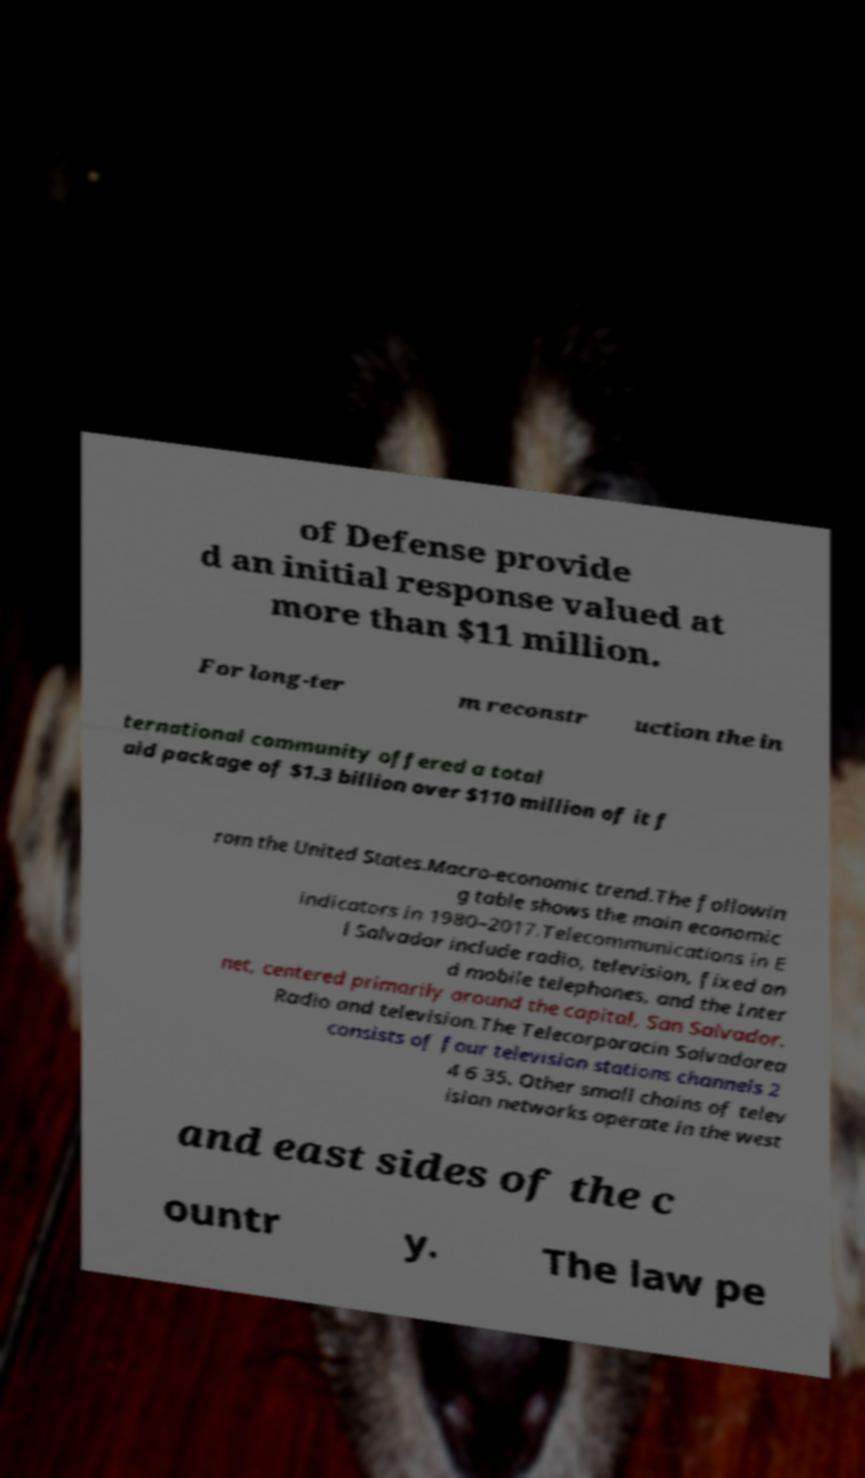I need the written content from this picture converted into text. Can you do that? of Defense provide d an initial response valued at more than $11 million. For long-ter m reconstr uction the in ternational community offered a total aid package of $1.3 billion over $110 million of it f rom the United States.Macro-economic trend.The followin g table shows the main economic indicators in 1980–2017.Telecommunications in E l Salvador include radio, television, fixed an d mobile telephones, and the Inter net, centered primarily around the capital, San Salvador. Radio and television.The Telecorporacin Salvadorea consists of four television stations channels 2 4 6 35. Other small chains of telev ision networks operate in the west and east sides of the c ountr y. The law pe 